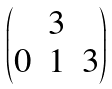<formula> <loc_0><loc_0><loc_500><loc_500>\begin{pmatrix} & 3 & \\ 0 & 1 & 3 \end{pmatrix}</formula> 